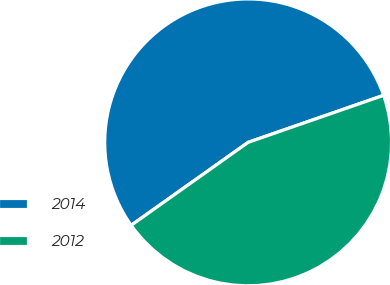<chart> <loc_0><loc_0><loc_500><loc_500><pie_chart><fcel>2014<fcel>2012<nl><fcel>54.5%<fcel>45.5%<nl></chart> 